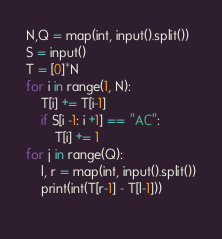Convert code to text. <code><loc_0><loc_0><loc_500><loc_500><_Python_>N,Q = map(int, input().split())
S = input()
T = [0]*N
for i in range(1, N):
    T[i] += T[i-1]
    if S[i -1: i +1] == "AC":
        T[i] += 1
for j in range(Q):
    l, r = map(int, input().split())
    print(int(T[r-1] - T[l-1]))
    </code> 